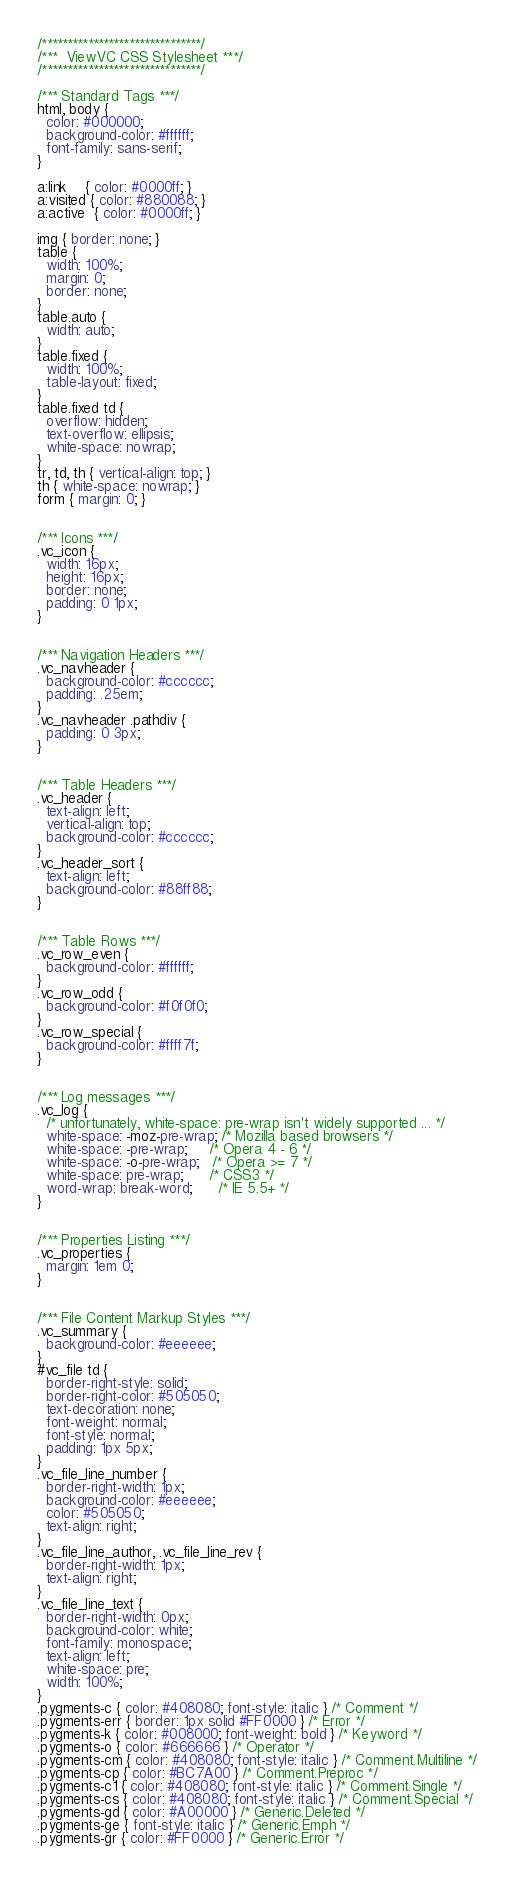<code> <loc_0><loc_0><loc_500><loc_500><_CSS_>/*******************************/
/***  ViewVC CSS Stylesheet ***/
/*******************************/

/*** Standard Tags ***/
html, body {
  color: #000000;
  background-color: #ffffff;
  font-family: sans-serif;
}

a:link    { color: #0000ff; }
a:visited { color: #880088; }
a:active  { color: #0000ff; }

img { border: none; }
table {
  width: 100%;
  margin: 0; 
  border: none;
}
table.auto {
  width: auto;
}
table.fixed {
  width: 100%;
  table-layout: fixed;
}
table.fixed td {
  overflow: hidden; 
  text-overflow: ellipsis;
  white-space: nowrap;
}
tr, td, th { vertical-align: top; }
th { white-space: nowrap; }
form { margin: 0; }


/*** Icons ***/
.vc_icon {
  width: 16px;
  height: 16px;
  border: none;
  padding: 0 1px;
}


/*** Navigation Headers ***/
.vc_navheader {
  background-color: #cccccc;
  padding: .25em;
}
.vc_navheader .pathdiv {
  padding: 0 3px;
}


/*** Table Headers ***/
.vc_header {
  text-align: left;
  vertical-align: top;
  background-color: #cccccc;
}
.vc_header_sort {
  text-align: left;
  background-color: #88ff88;
}


/*** Table Rows ***/
.vc_row_even {
  background-color: #ffffff;
}
.vc_row_odd {
  background-color: #f0f0f0;
}
.vc_row_special {
  background-color: #ffff7f;
}


/*** Log messages ***/
.vc_log {
  /* unfortunately, white-space: pre-wrap isn't widely supported ... */
  white-space: -moz-pre-wrap; /* Mozilla based browsers */
  white-space: -pre-wrap;     /* Opera 4 - 6 */
  white-space: -o-pre-wrap;   /* Opera >= 7 */
  white-space: pre-wrap;      /* CSS3 */
  word-wrap: break-word;      /* IE 5.5+ */
}


/*** Properties Listing ***/
.vc_properties {
  margin: 1em 0;
}


/*** File Content Markup Styles ***/
.vc_summary {
  background-color: #eeeeee;
}
#vc_file td {
  border-right-style: solid;
  border-right-color: #505050;
  text-decoration: none;
  font-weight: normal;
  font-style: normal;
  padding: 1px 5px;
}
.vc_file_line_number {
  border-right-width: 1px;
  background-color: #eeeeee;
  color: #505050;
  text-align: right;
}
.vc_file_line_author, .vc_file_line_rev {
  border-right-width: 1px;
  text-align: right;
}
.vc_file_line_text {
  border-right-width: 0px;
  background-color: white;
  font-family: monospace;
  text-align: left;
  white-space: pre;
  width: 100%;
}
.pygments-c { color: #408080; font-style: italic } /* Comment */
.pygments-err { border: 1px solid #FF0000 } /* Error */
.pygments-k { color: #008000; font-weight: bold } /* Keyword */
.pygments-o { color: #666666 } /* Operator */
.pygments-cm { color: #408080; font-style: italic } /* Comment.Multiline */
.pygments-cp { color: #BC7A00 } /* Comment.Preproc */
.pygments-c1 { color: #408080; font-style: italic } /* Comment.Single */
.pygments-cs { color: #408080; font-style: italic } /* Comment.Special */
.pygments-gd { color: #A00000 } /* Generic.Deleted */
.pygments-ge { font-style: italic } /* Generic.Emph */
.pygments-gr { color: #FF0000 } /* Generic.Error */</code> 